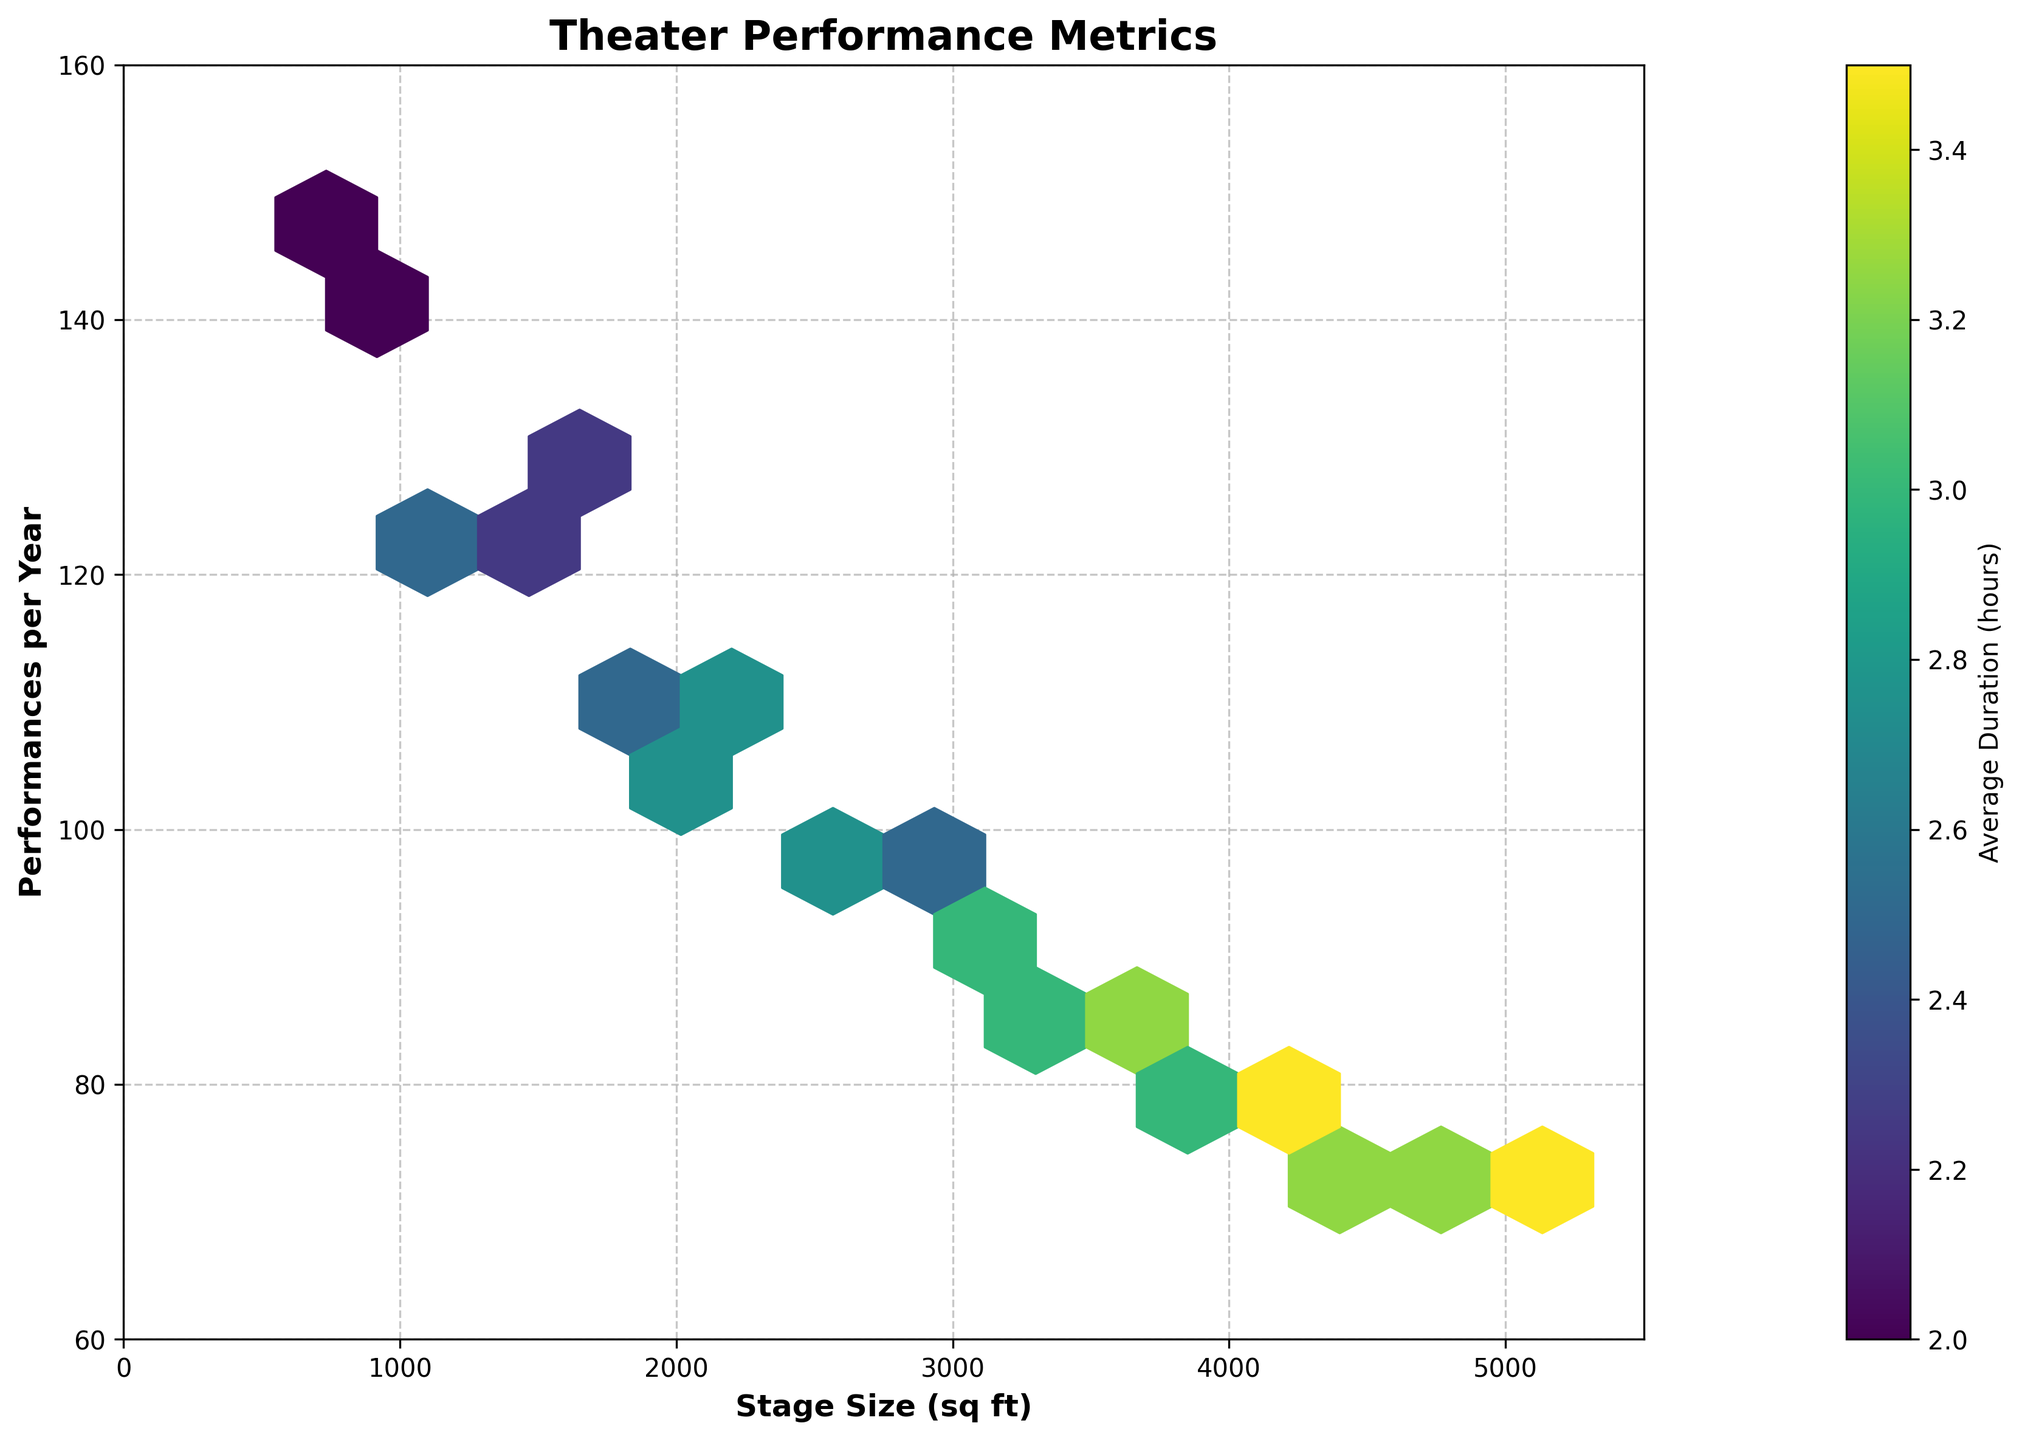What's the title of the figure? The title of a figure is usually located at the top center and provides a brief description of the plot. In this case, the title is "Theater Performance Metrics".
Answer: Theater Performance Metrics What do the colors represent in the hexbin plot? In a hexbin plot, colors often represent an additional variable. Here, the color bar indicates that the colors represent the "Average Duration (hours)" of the stage performances.
Answer: Average Duration (hours) Where do you find the highest concentration of performances per year on stages sized between 2000 and 3000 square feet? Looking at the hexbin plot, you can identify the highest concentration by finding the densest color cluster within the specified stage size range. Between 2000 and 3000 sq ft, the highest concentration is near the 100 performances per year mark.
Answer: Around 100 performances per year Which stage size has the highest performance per year in this dataset? By examining the highest y-value (Performances per Year) in the plot, you can see that stages around 800-1000 sq ft have the highest performances, close to 150 per year.
Answer: Around 800-1000 sq ft Do larger stage sizes correlate with longer average durations? To determine the correlation, observe the color gradient and trend of the hexes as stage size increases. Larger stage sizes (darker colors) do show a tendency for longer durations on average.
Answer: Yes What's the average duration range for stages between 4000 and 5000 sq ft? Identify the color of the hexagons within the 4000-5000 sq ft range, then match them to the color bar. The colors correspond to durations between 3 and 3.5 hours.
Answer: Between 3 and 3.5 hours In terms of performance frequency, which range of stage sizes shows the most significant drop? Track the performance frequency as the stage size increases. Notice the steep decline from small stages (800-1000 sq ft) with high performances to larger stages (3000-5000 sq ft) with significantly lower performances.
Answer: From 800-1000 sq ft to 3000-5000 sq ft What's the general trend between stage size and the number of performances per year? By observing the overall distribution of the hex bins, there seems to be a negative correlation: as the stage size increases, the number of performances per year generally decreases.
Answer: Negative correlation Are there any stages sized above 4500 sq ft with an average duration of less than 2.5 hours? Compare the hexbin colors associated with stages sized above 4500 sq ft to the color bar range. Such hexbins do not correspond to colors indicating durations less than 2.5 hours.
Answer: No 